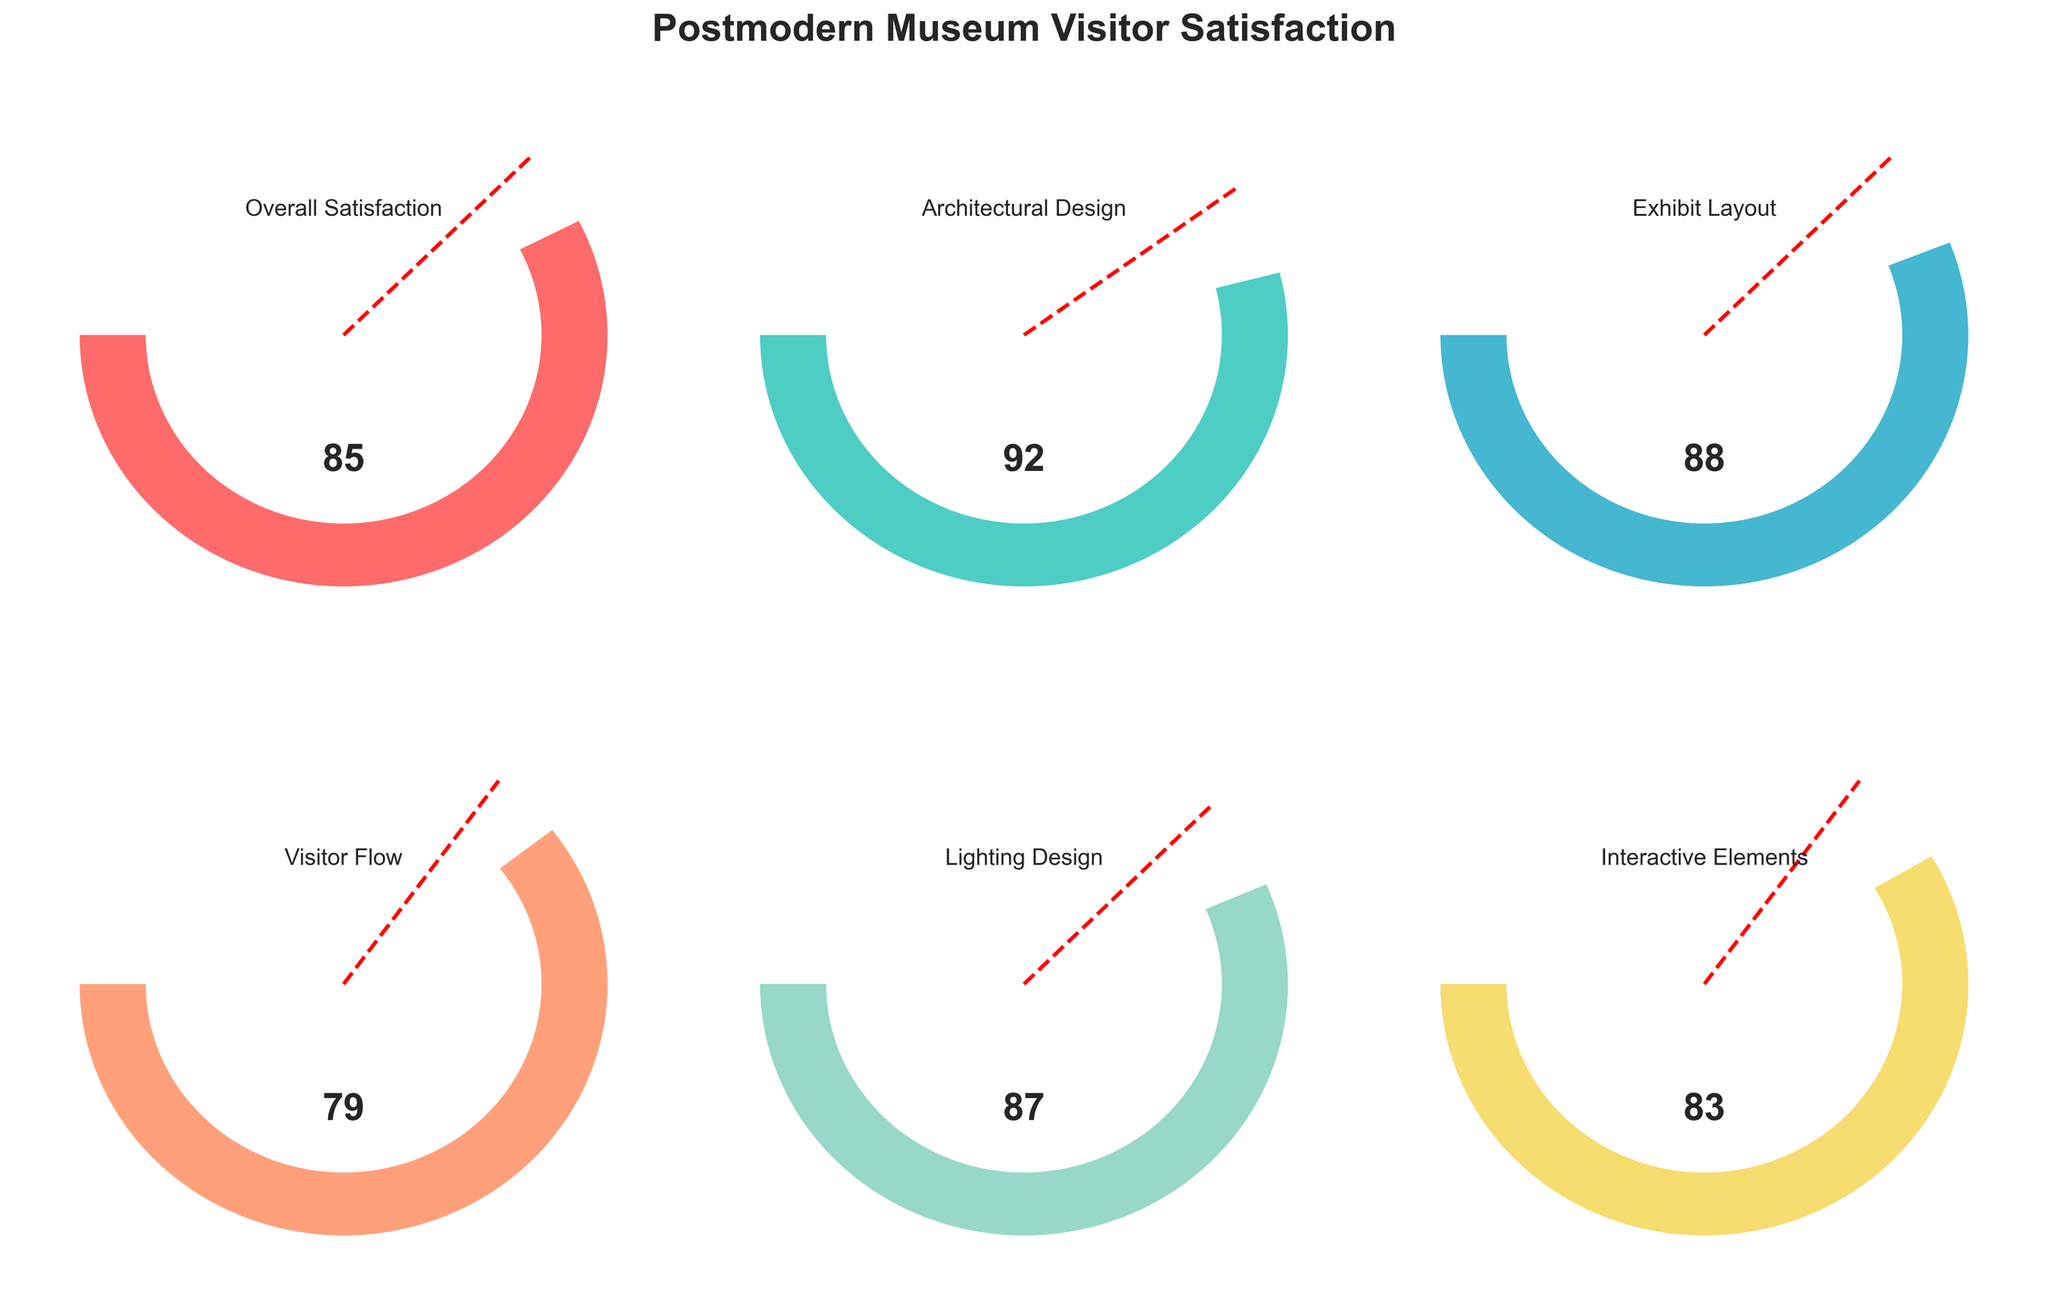What is the overall visitor satisfaction score for the postmodern museum? The figure shows a gauge for overall visitor satisfaction, with the pointer indicating the value.
Answer: 85 Which aspect has the highest satisfaction score? By comparing all the gauges, the Architectural Design gauge has the highest value.
Answer: Architectural Design What is the satisfaction score for the Exhibit Layout? The gauge for Exhibit Layout indicates the score.
Answer: 88 How many aspects have satisfaction scores above their respective thresholds? By checking each gauge, the following aspects are above their thresholds: Overall Satisfaction, Architectural Design, Exhibit Layout, Lighting Design, Interactive Elements.
Answer: 5 Which aspect has the lowest satisfaction score? By comparing all gauges, Visitor Flow has the lowest value.
Answer: Visitor Flow Is the Lighting Design score above its threshold? The threshold is 75, and the Lighting Design score is 87, which is above the threshold.
Answer: Yes How does the Visitor Flow satisfaction score compare to the threshold for the same aspect? The Visitor Flow score is 79, and the threshold is 70. Hence, the score is higher.
Answer: It is above the threshold What is the average satisfaction score of all aspects? Add all the scores (85 + 92 + 88 + 79 + 87 + 83) to get 514 and divide by the number of aspects (6). So, the average satisfaction score is 514/6.
Answer: 85.67 Which aspect's score is closest to 80? Comparing all scores to 80, Visitor Flow has a score of 79, which is closest.
Answer: Visitor Flow Is the Interactive Elements score above or below the Overall Satisfaction score? The Interactive Elements score is 83, and the Overall Satisfaction score is 85, so it is below.
Answer: Below 